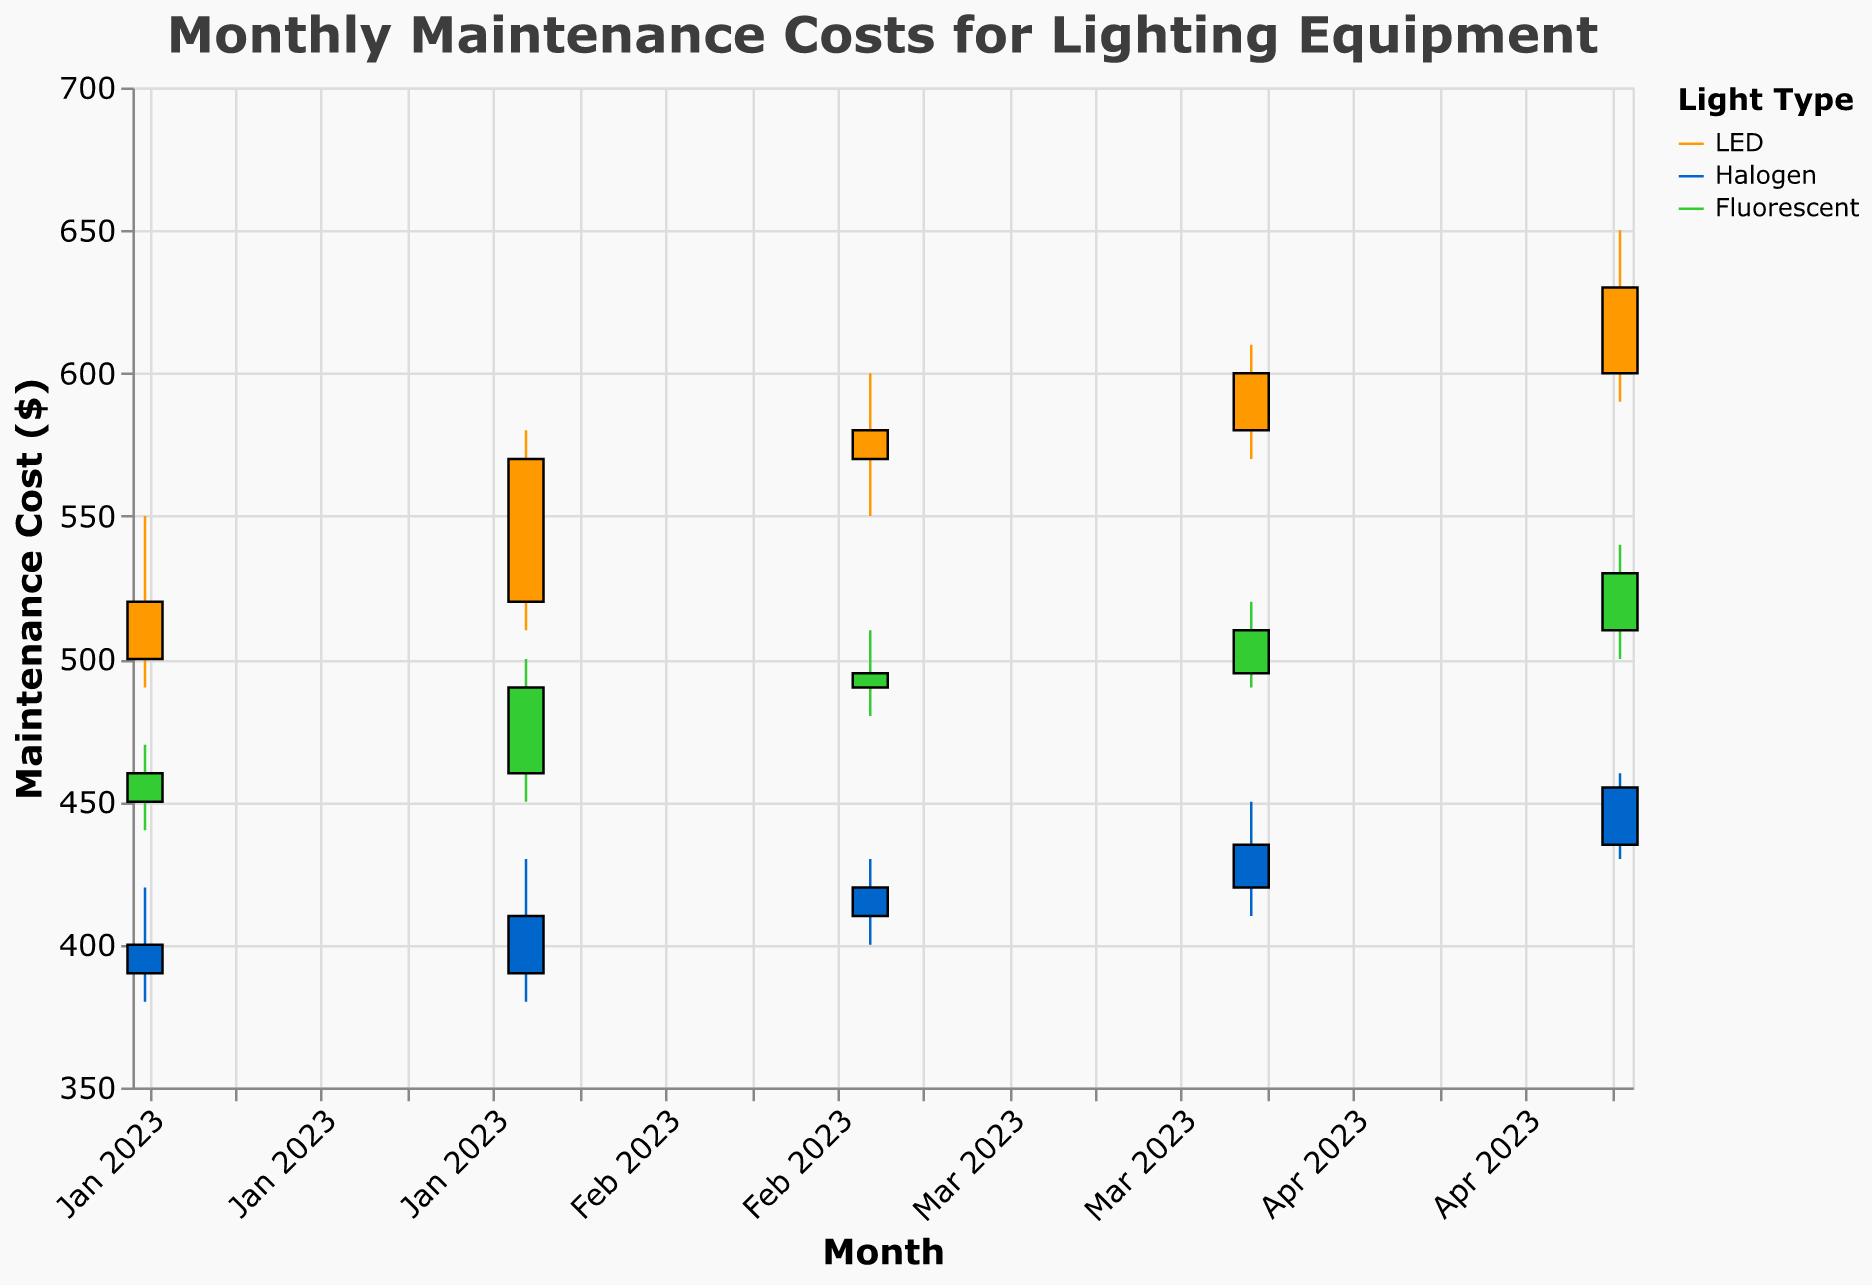What's the title of the figure? The title of the figure is displayed at the top, indicating the main focus of the visualization. By reading the title, you can understand the overall subject of the chart.
Answer: Monthly Maintenance Costs for Lighting Equipment What are the three types of lighting equipment shown in the plot? The color legend on the right side of the figure segregates the data by type, each represented by a different color. The types listed there are LED, Halogen, and Fluorescent.
Answer: LED, Halogen, Fluorescent What is the highest maintenance cost recorded for Halogen lights, and in which month did it occur? By observing the candlestick representing Halogen lights, you can identify the highest value point on the y-axis. The highest point is 460, and it occurred in May 2023.
Answer: 460, May 2023 How did the maintenance cost for LED lights change from January to May 2023? Examine the open, high, low, and close points for LED lights from January to May. Note the trend in the close prices over these months. The cost increased from 520 in January to 630 in May.
Answer: It increased from 520 to 630 Which month experienced the lowest maintenance cost for Fluorescent lights, and what was the value? The lowest point can be found by looking at the "Low" values for Fluorescent lights across all months. The lowest value is 440, occurring in January 2023.
Answer: January 2023, 440 Compare the range of maintenance costs (difference between High and Low) for LED and Halogen lights in March 2023. Which type had a wider range? Calculate the range for each type (High - Low). For LED in March, it's 600 - 550 = 50. For Halogen, it's 430 - 400 = 30. LED had a wider range.
Answer: LED had a wider range What was the average closing cost for Halogen lights over the given months? Sum the close values for each month (390 + 410 + 420 + 435 + 455) and divide by the number of months (5). The calculation is (390 + 410 + 420 + 435 + 455) / 5 = 422.
Answer: 422 In which month did LED lights show the highest increase in maintenance cost within the same month, and what was that increase? The highest increase is the difference between Open and Close prices. Check each month: January (520-500=20), February (570-520=50), March (580-570=10), April (600-580=20), May (630-600=30). The largest increase is 50, occurring in February 2023.
Answer: February 2023, 50 What's the overall trend in the maintenance costs for Fluorescent lights from January to May 2023? By tracking the close values for Fluorescent lights sequentially from January (460) to May (530), we see a general increasing trend.
Answer: Increasing 